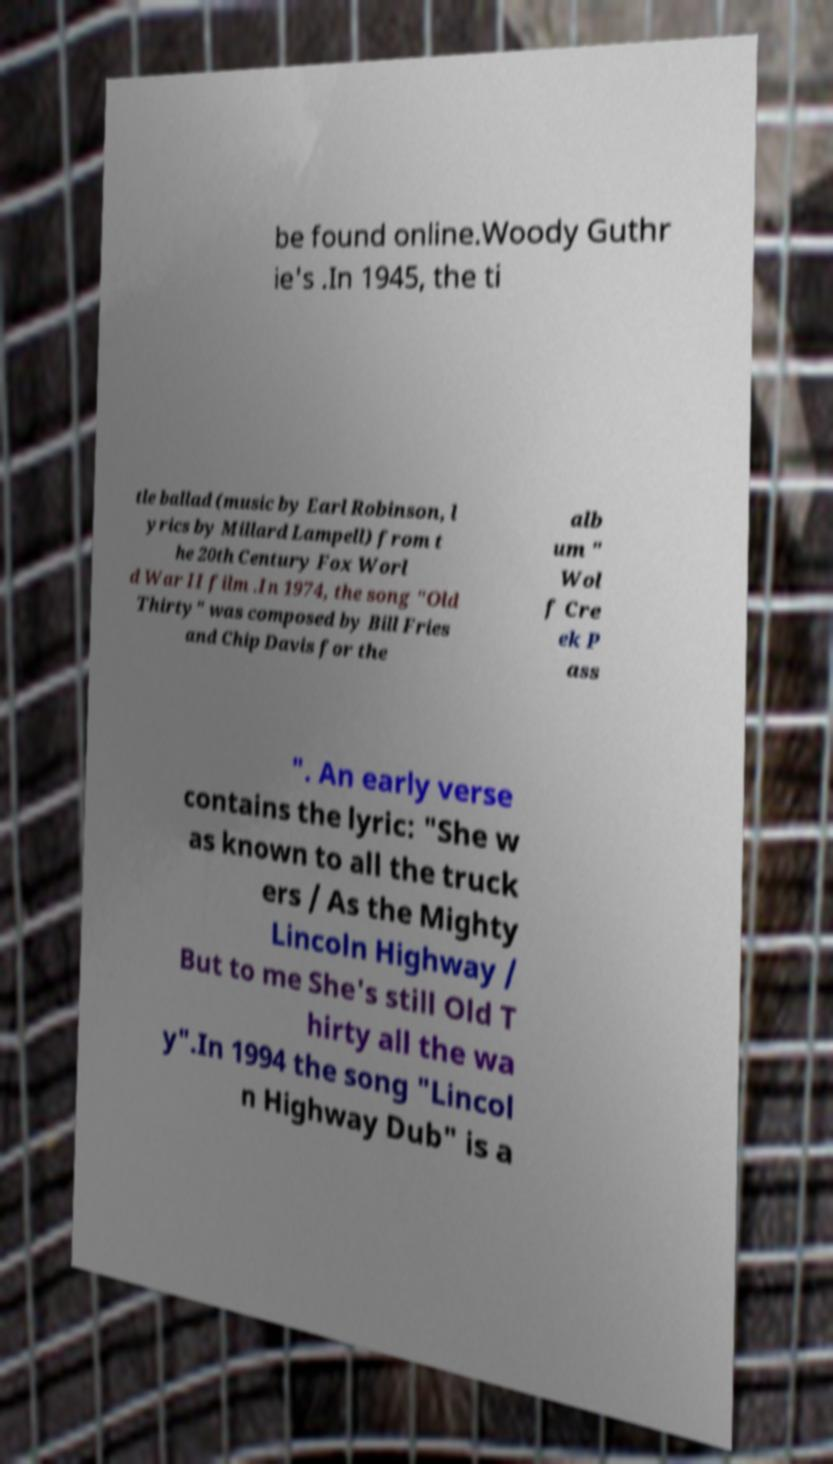For documentation purposes, I need the text within this image transcribed. Could you provide that? be found online.Woody Guthr ie's .In 1945, the ti tle ballad (music by Earl Robinson, l yrics by Millard Lampell) from t he 20th Century Fox Worl d War II film .In 1974, the song "Old Thirty" was composed by Bill Fries and Chip Davis for the alb um " Wol f Cre ek P ass ". An early verse contains the lyric: "She w as known to all the truck ers / As the Mighty Lincoln Highway / But to me She's still Old T hirty all the wa y".In 1994 the song "Lincol n Highway Dub" is a 